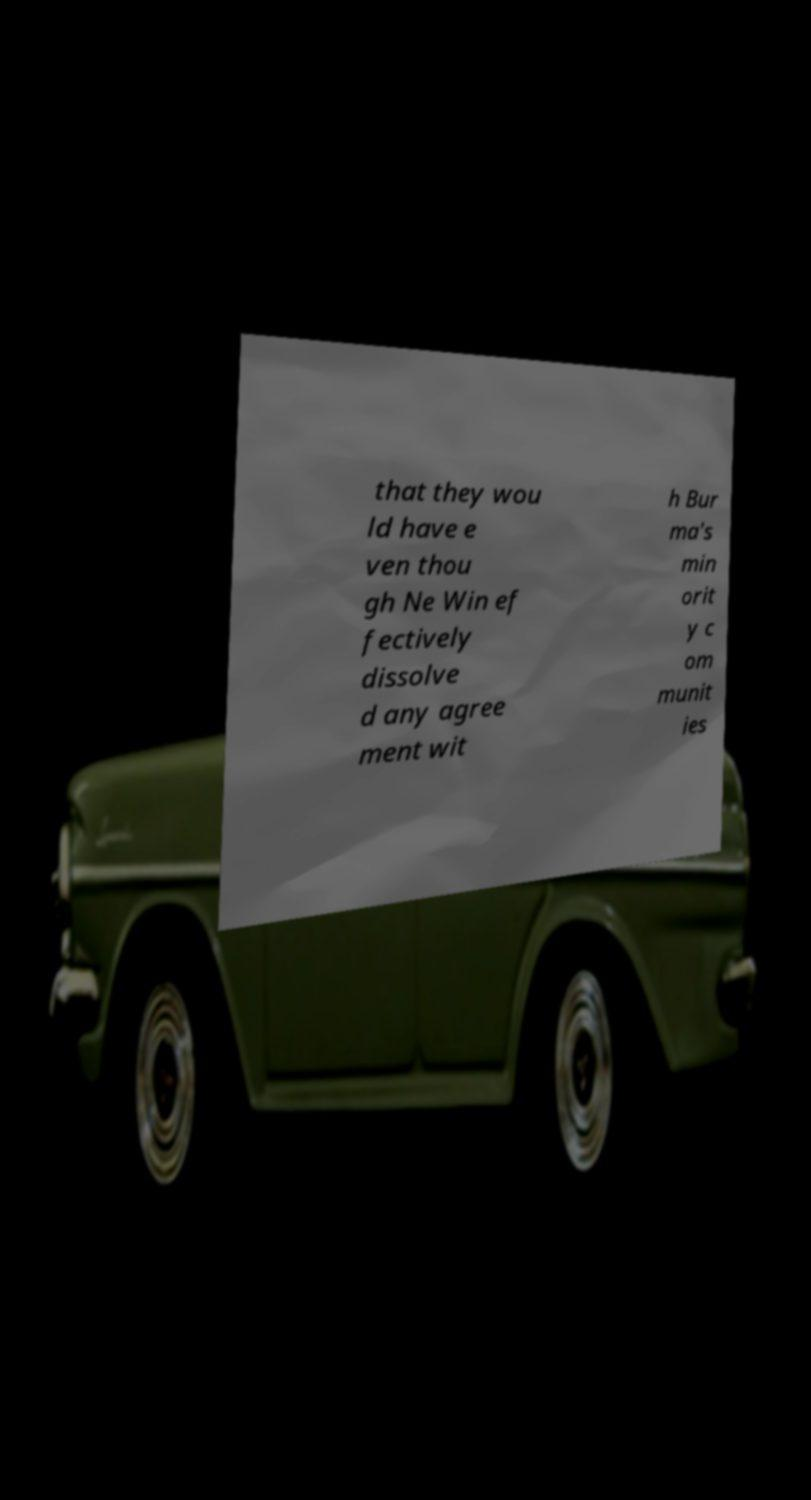What messages or text are displayed in this image? I need them in a readable, typed format. that they wou ld have e ven thou gh Ne Win ef fectively dissolve d any agree ment wit h Bur ma's min orit y c om munit ies 